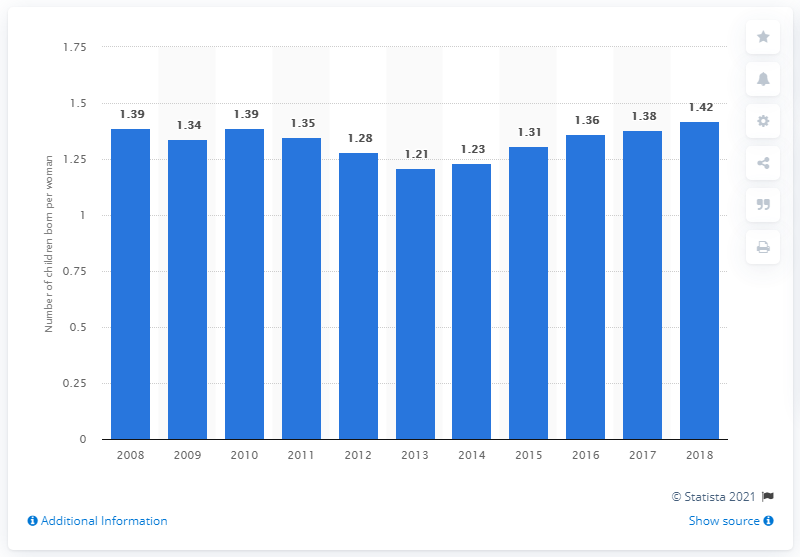Can you describe the trend in Portugal's fertility rate from 2008 to 2018? The trend in Portugal's fertility rate from 2008 to 2018 shows an initial decrease from 1.39 in 2008 to a low of 1.21 in 2013, followed by a gradual increase up to 1.42 in 2018 as depicted in the graph. 